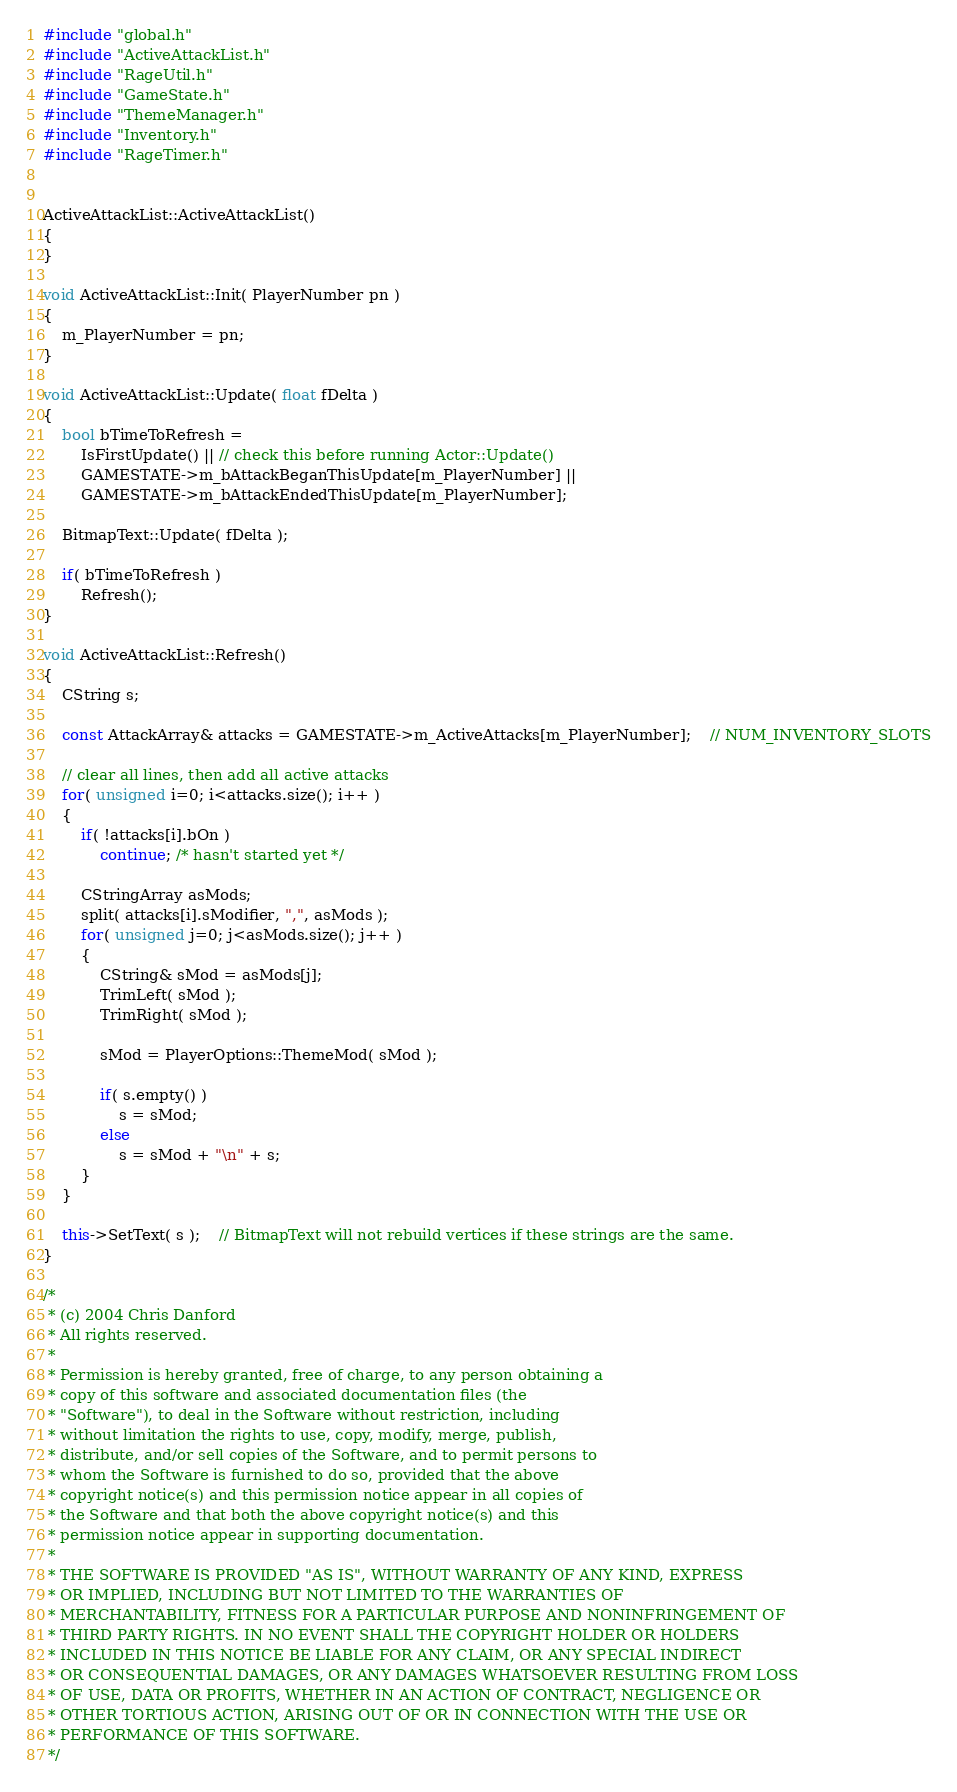<code> <loc_0><loc_0><loc_500><loc_500><_C++_>#include "global.h"
#include "ActiveAttackList.h"
#include "RageUtil.h"
#include "GameState.h"
#include "ThemeManager.h"
#include "Inventory.h"
#include "RageTimer.h"


ActiveAttackList::ActiveAttackList()
{
}

void ActiveAttackList::Init( PlayerNumber pn )
{
	m_PlayerNumber = pn;
}

void ActiveAttackList::Update( float fDelta ) 
{
	bool bTimeToRefresh = 
		IsFirstUpdate() || // check this before running Actor::Update()
		GAMESTATE->m_bAttackBeganThisUpdate[m_PlayerNumber] ||
		GAMESTATE->m_bAttackEndedThisUpdate[m_PlayerNumber];

	BitmapText::Update( fDelta ); 

	if( bTimeToRefresh )
		Refresh();
}

void ActiveAttackList::Refresh()
{
	CString s;

	const AttackArray& attacks = GAMESTATE->m_ActiveAttacks[m_PlayerNumber];	// NUM_INVENTORY_SLOTS
	
	// clear all lines, then add all active attacks
	for( unsigned i=0; i<attacks.size(); i++ )
	{
		if( !attacks[i].bOn )
			continue; /* hasn't started yet */

		CStringArray asMods;
		split( attacks[i].sModifier, ",", asMods );
		for( unsigned j=0; j<asMods.size(); j++ )
		{
			CString& sMod = asMods[j];
			TrimLeft( sMod );
			TrimRight( sMod );

			sMod = PlayerOptions::ThemeMod( sMod );

			if( s.empty() )
				s = sMod;
			else
				s = sMod + "\n" + s;
		}
	}

	this->SetText( s );	// BitmapText will not rebuild vertices if these strings are the same.
}

/*
 * (c) 2004 Chris Danford
 * All rights reserved.
 * 
 * Permission is hereby granted, free of charge, to any person obtaining a
 * copy of this software and associated documentation files (the
 * "Software"), to deal in the Software without restriction, including
 * without limitation the rights to use, copy, modify, merge, publish,
 * distribute, and/or sell copies of the Software, and to permit persons to
 * whom the Software is furnished to do so, provided that the above
 * copyright notice(s) and this permission notice appear in all copies of
 * the Software and that both the above copyright notice(s) and this
 * permission notice appear in supporting documentation.
 * 
 * THE SOFTWARE IS PROVIDED "AS IS", WITHOUT WARRANTY OF ANY KIND, EXPRESS
 * OR IMPLIED, INCLUDING BUT NOT LIMITED TO THE WARRANTIES OF
 * MERCHANTABILITY, FITNESS FOR A PARTICULAR PURPOSE AND NONINFRINGEMENT OF
 * THIRD PARTY RIGHTS. IN NO EVENT SHALL THE COPYRIGHT HOLDER OR HOLDERS
 * INCLUDED IN THIS NOTICE BE LIABLE FOR ANY CLAIM, OR ANY SPECIAL INDIRECT
 * OR CONSEQUENTIAL DAMAGES, OR ANY DAMAGES WHATSOEVER RESULTING FROM LOSS
 * OF USE, DATA OR PROFITS, WHETHER IN AN ACTION OF CONTRACT, NEGLIGENCE OR
 * OTHER TORTIOUS ACTION, ARISING OUT OF OR IN CONNECTION WITH THE USE OR
 * PERFORMANCE OF THIS SOFTWARE.
 */
</code> 